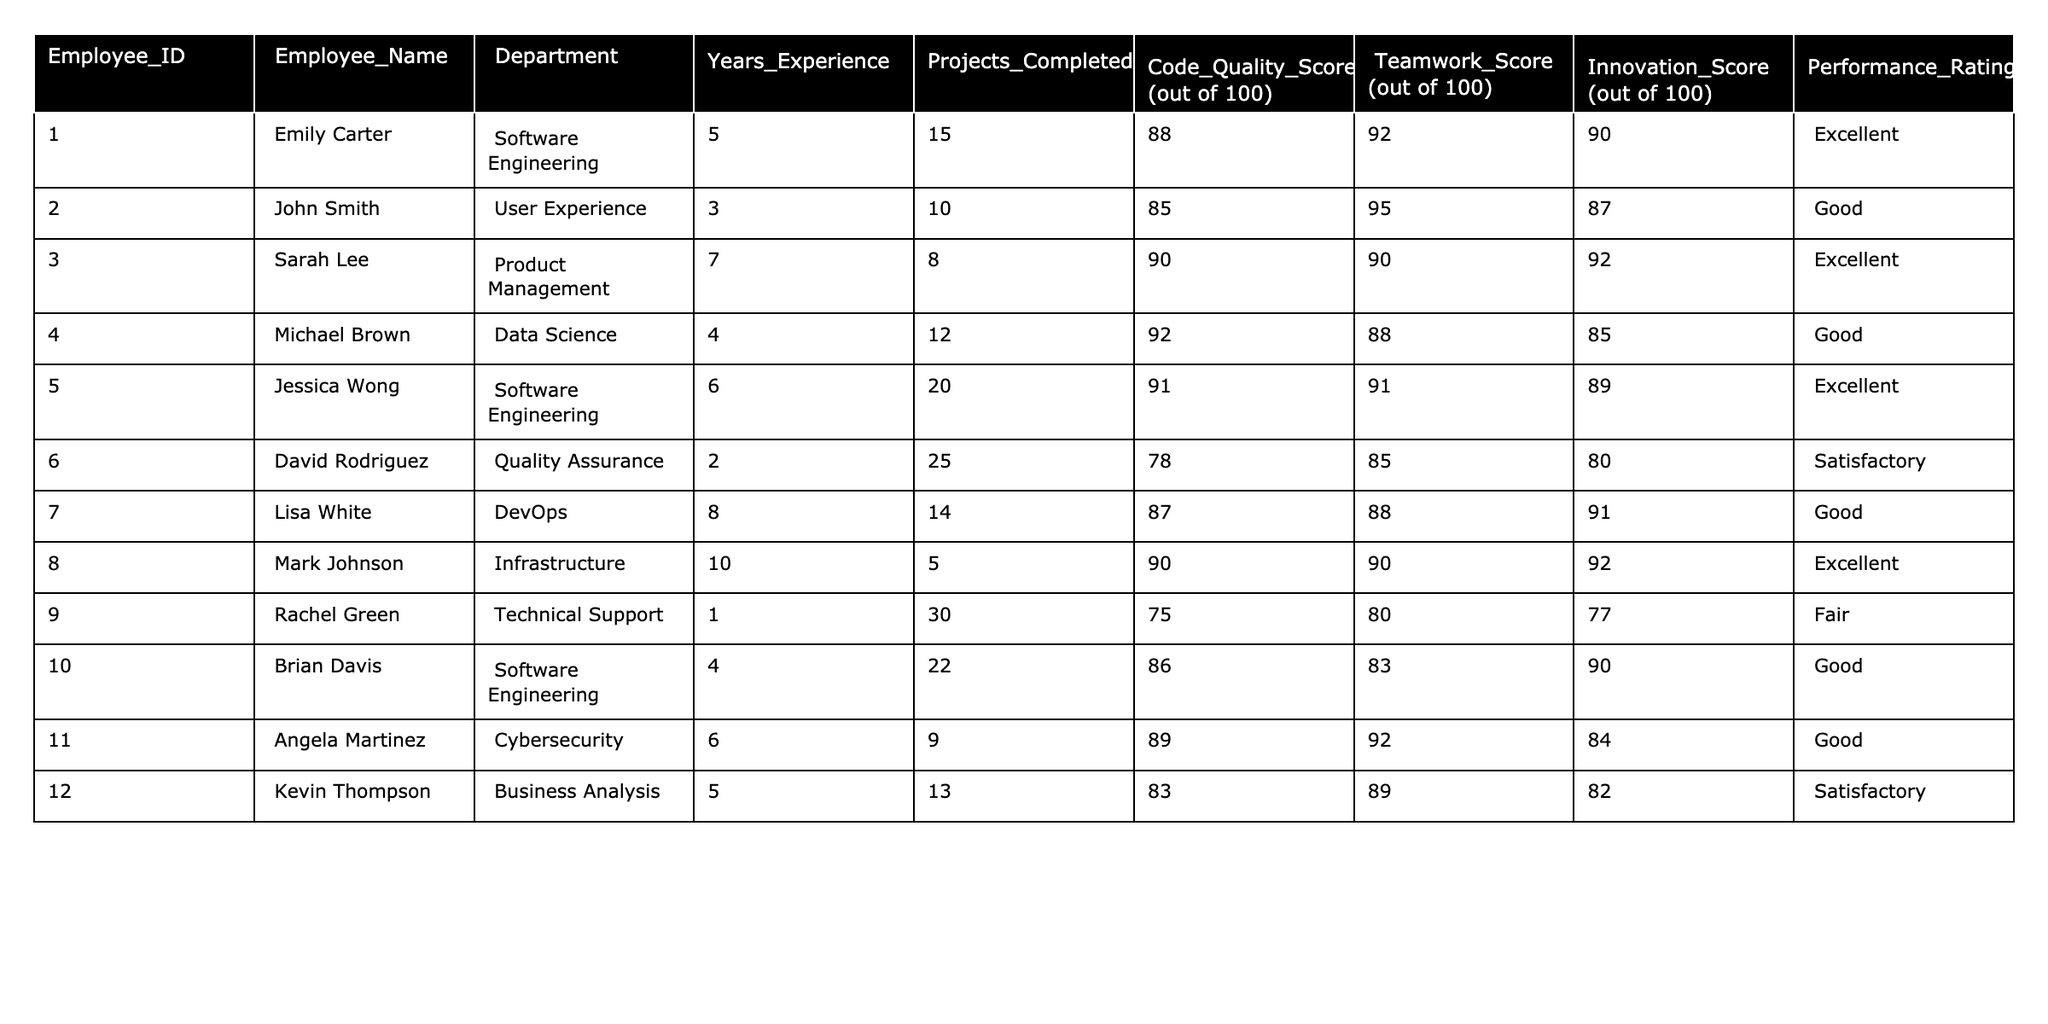What is the highest Code Quality Score among the employees? By reviewing the Code Quality Scores in the table, I note that the scores are: 88, 85, 90, 92, 91, 78, 87, 90, 75, 86, 89, and 83. The highest score is 92.
Answer: 92 How many projects did Jessica Wong complete? Referring to the Projects Completed column, Jessica Wong has completed 20 projects.
Answer: 20 Is Rachel Green's Performance Rating "Good"? Evaluating the Performance Ratings in the table, Rachel Green's rating is "Fair," which is not "Good."
Answer: No What is the average Teamwork Score of employees in the User Experience and Software Engineering departments? The Teamwork Scores for these departments are: User Experience - 95 and Software Engineering - 92, 91, 83. First, sum them: 95 + 92 + 91 + 83 = 361. Then, divide by the count of employees in these departments: 4. Thus, the average is 361/4 = 90.25.
Answer: 90.25 How many employees have more than 5 years of experience? Looking at the Years Experience column, the applicable employees are Sarah Lee (7), Jessica Wong (6), Mark Johnson (10), and Lisa White (8). Thus, there are 4 employees with more than 5 years of experience.
Answer: 4 What is the difference in Projects Completed between Emily Carter and David Rodriguez? Emily Carter completed 15 projects and David Rodriguez completed 25 projects. Calculating the difference: 25 - 15 = 10.
Answer: 10 Which department has the highest average Innovation Score? The average Innovation Scores per department are: Software Engineering (90 + 89)/2 = 89.5, User Experience (87), Product Management (92), Data Science (85), Quality Assurance (80), DevOps (91), Infrastructure (92), Technical Support (77), Cybersecurity (84), and Business Analysis (82). The highest average is 89.5 for Software Engineering.
Answer: Software Engineering Who completed the least projects? Inspecting the Projects Completed column, I find Rachel Green completed 30 projects, which is the highest. The lowest number is 5 projects, completed by Mark Johnson.
Answer: Mark Johnson Is there an employee with a Performance Rating of "Satisfactory" who completed more than 10 projects? Checking the Performance Ratings, David Rodriguez has a "Satisfactory" rating and completed 25 projects. Therefore, the answer is yes.
Answer: Yes Calculate the total Code Quality Score for employees in the Data Science and Cybersecurity departments. The Code Quality Scores for these departments are: Data Science - 92, and Cybersecurity - 89. Adding these scores gives: 92 + 89 = 181.
Answer: 181 